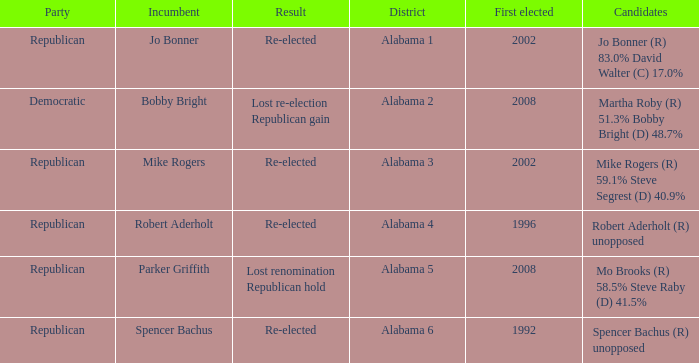Name the incumbent for alabama 6 Spencer Bachus. 